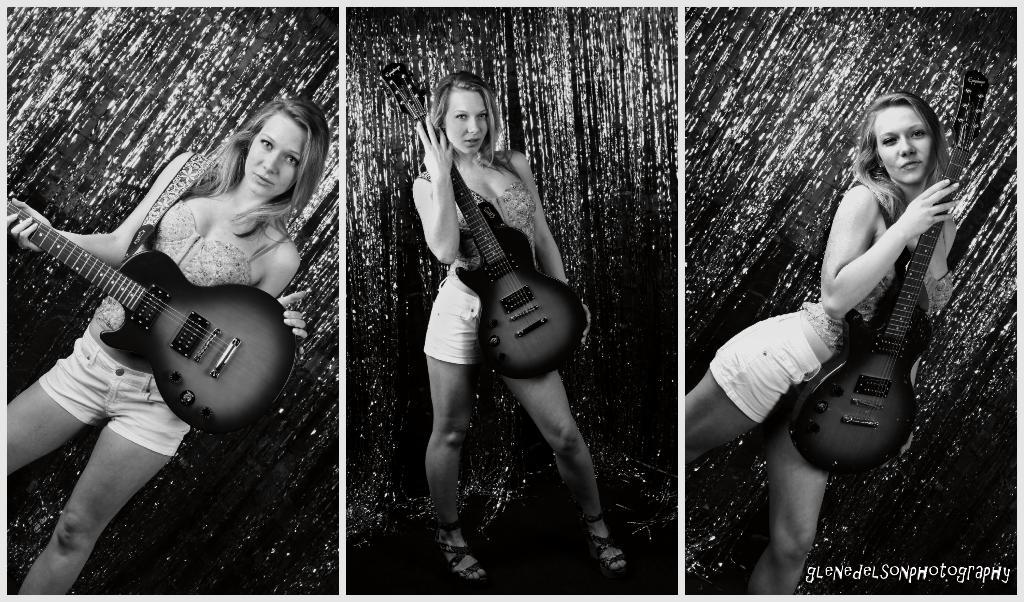What is the main subject of the image? The main subject of the image is a woman. What is the woman holding in the image? The woman is holding a guitar. What type of carriage can be seen in the image? There is no carriage present in the image; it features a woman holding a guitar. What type of polish is the woman applying to her nails in the image? There is no indication in the image that the woman is applying any polish to her nails, as her hands are occupied with holding the guitar. 